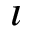Convert formula to latex. <formula><loc_0><loc_0><loc_500><loc_500>\imath</formula> 